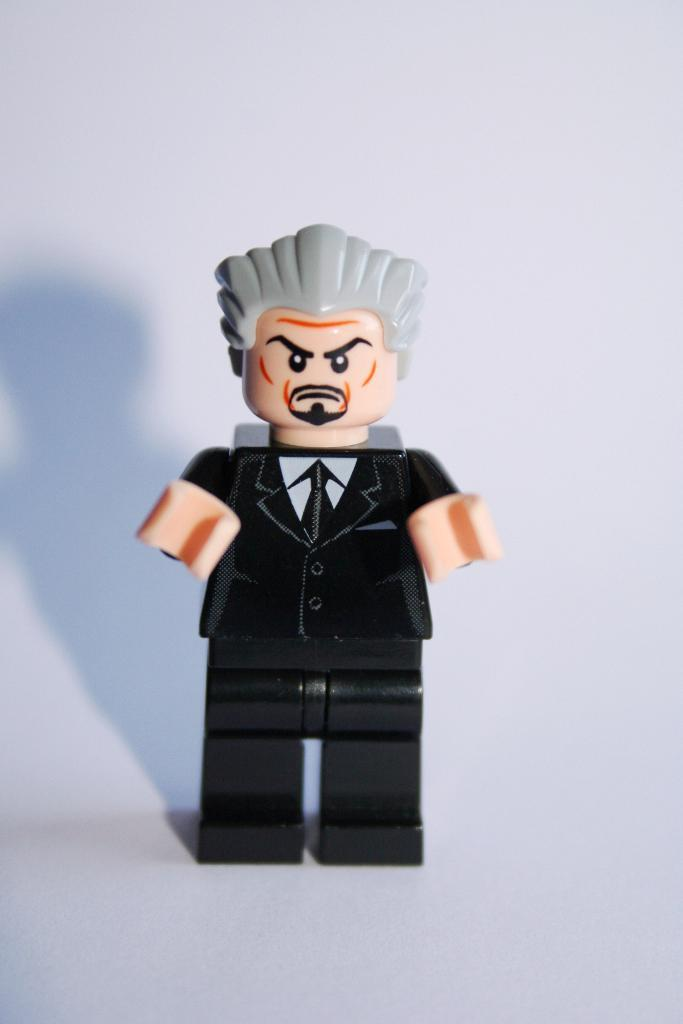What is the main subject in the center of the image? There is a human figure model toy in the center of the image. What can be seen in the background of the image? There is a wall in the background of the image. Where is the kitty playing with the bait in the image? There is no kitty or bait present in the image. 